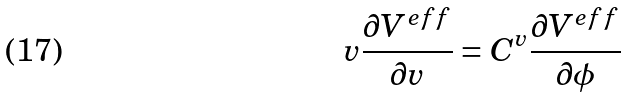<formula> <loc_0><loc_0><loc_500><loc_500>v \frac { \partial V ^ { e f f } } { \partial v } = C ^ { v } \frac { \partial V ^ { e f f } } { \partial \phi }</formula> 